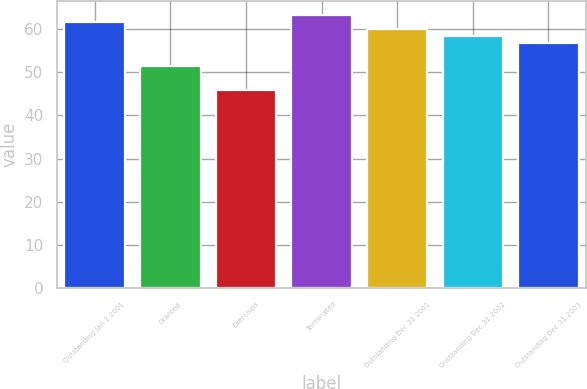<chart> <loc_0><loc_0><loc_500><loc_500><bar_chart><fcel>Outstanding Jan 1 2001<fcel>Granted<fcel>Exercised<fcel>Terminated<fcel>Outstanding Dec 31 2001<fcel>Outstanding Dec 31 2002<fcel>Outstanding Dec 31 2003<nl><fcel>61.72<fcel>51.52<fcel>45.99<fcel>63.39<fcel>60.05<fcel>58.38<fcel>56.71<nl></chart> 